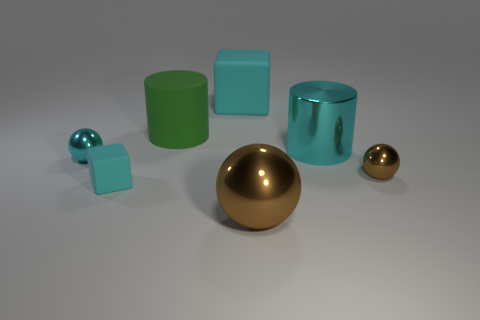Are there any objects in the image that have the same color but different shapes? Yes, the two cyan blocks are of the same color but different shapes; one is a cube and the other is a cylinder. 